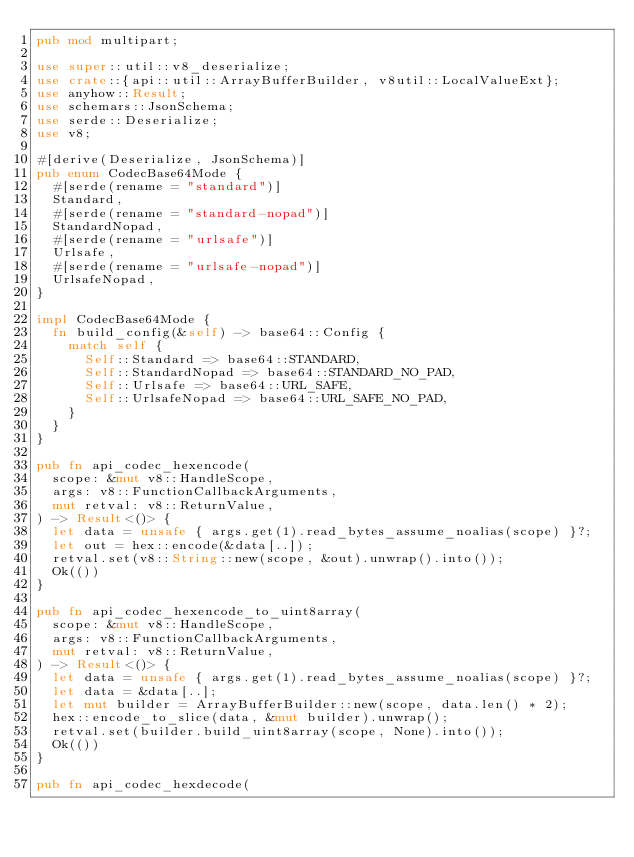Convert code to text. <code><loc_0><loc_0><loc_500><loc_500><_Rust_>pub mod multipart;

use super::util::v8_deserialize;
use crate::{api::util::ArrayBufferBuilder, v8util::LocalValueExt};
use anyhow::Result;
use schemars::JsonSchema;
use serde::Deserialize;
use v8;

#[derive(Deserialize, JsonSchema)]
pub enum CodecBase64Mode {
  #[serde(rename = "standard")]
  Standard,
  #[serde(rename = "standard-nopad")]
  StandardNopad,
  #[serde(rename = "urlsafe")]
  Urlsafe,
  #[serde(rename = "urlsafe-nopad")]
  UrlsafeNopad,
}

impl CodecBase64Mode {
  fn build_config(&self) -> base64::Config {
    match self {
      Self::Standard => base64::STANDARD,
      Self::StandardNopad => base64::STANDARD_NO_PAD,
      Self::Urlsafe => base64::URL_SAFE,
      Self::UrlsafeNopad => base64::URL_SAFE_NO_PAD,
    }
  }
}

pub fn api_codec_hexencode(
  scope: &mut v8::HandleScope,
  args: v8::FunctionCallbackArguments,
  mut retval: v8::ReturnValue,
) -> Result<()> {
  let data = unsafe { args.get(1).read_bytes_assume_noalias(scope) }?;
  let out = hex::encode(&data[..]);
  retval.set(v8::String::new(scope, &out).unwrap().into());
  Ok(())
}

pub fn api_codec_hexencode_to_uint8array(
  scope: &mut v8::HandleScope,
  args: v8::FunctionCallbackArguments,
  mut retval: v8::ReturnValue,
) -> Result<()> {
  let data = unsafe { args.get(1).read_bytes_assume_noalias(scope) }?;
  let data = &data[..];
  let mut builder = ArrayBufferBuilder::new(scope, data.len() * 2);
  hex::encode_to_slice(data, &mut builder).unwrap();
  retval.set(builder.build_uint8array(scope, None).into());
  Ok(())
}

pub fn api_codec_hexdecode(</code> 